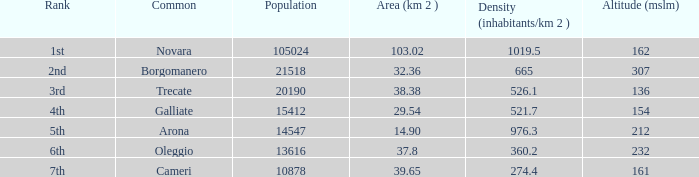What is the minimum altitude (mslm) in all the commons? 136.0. 